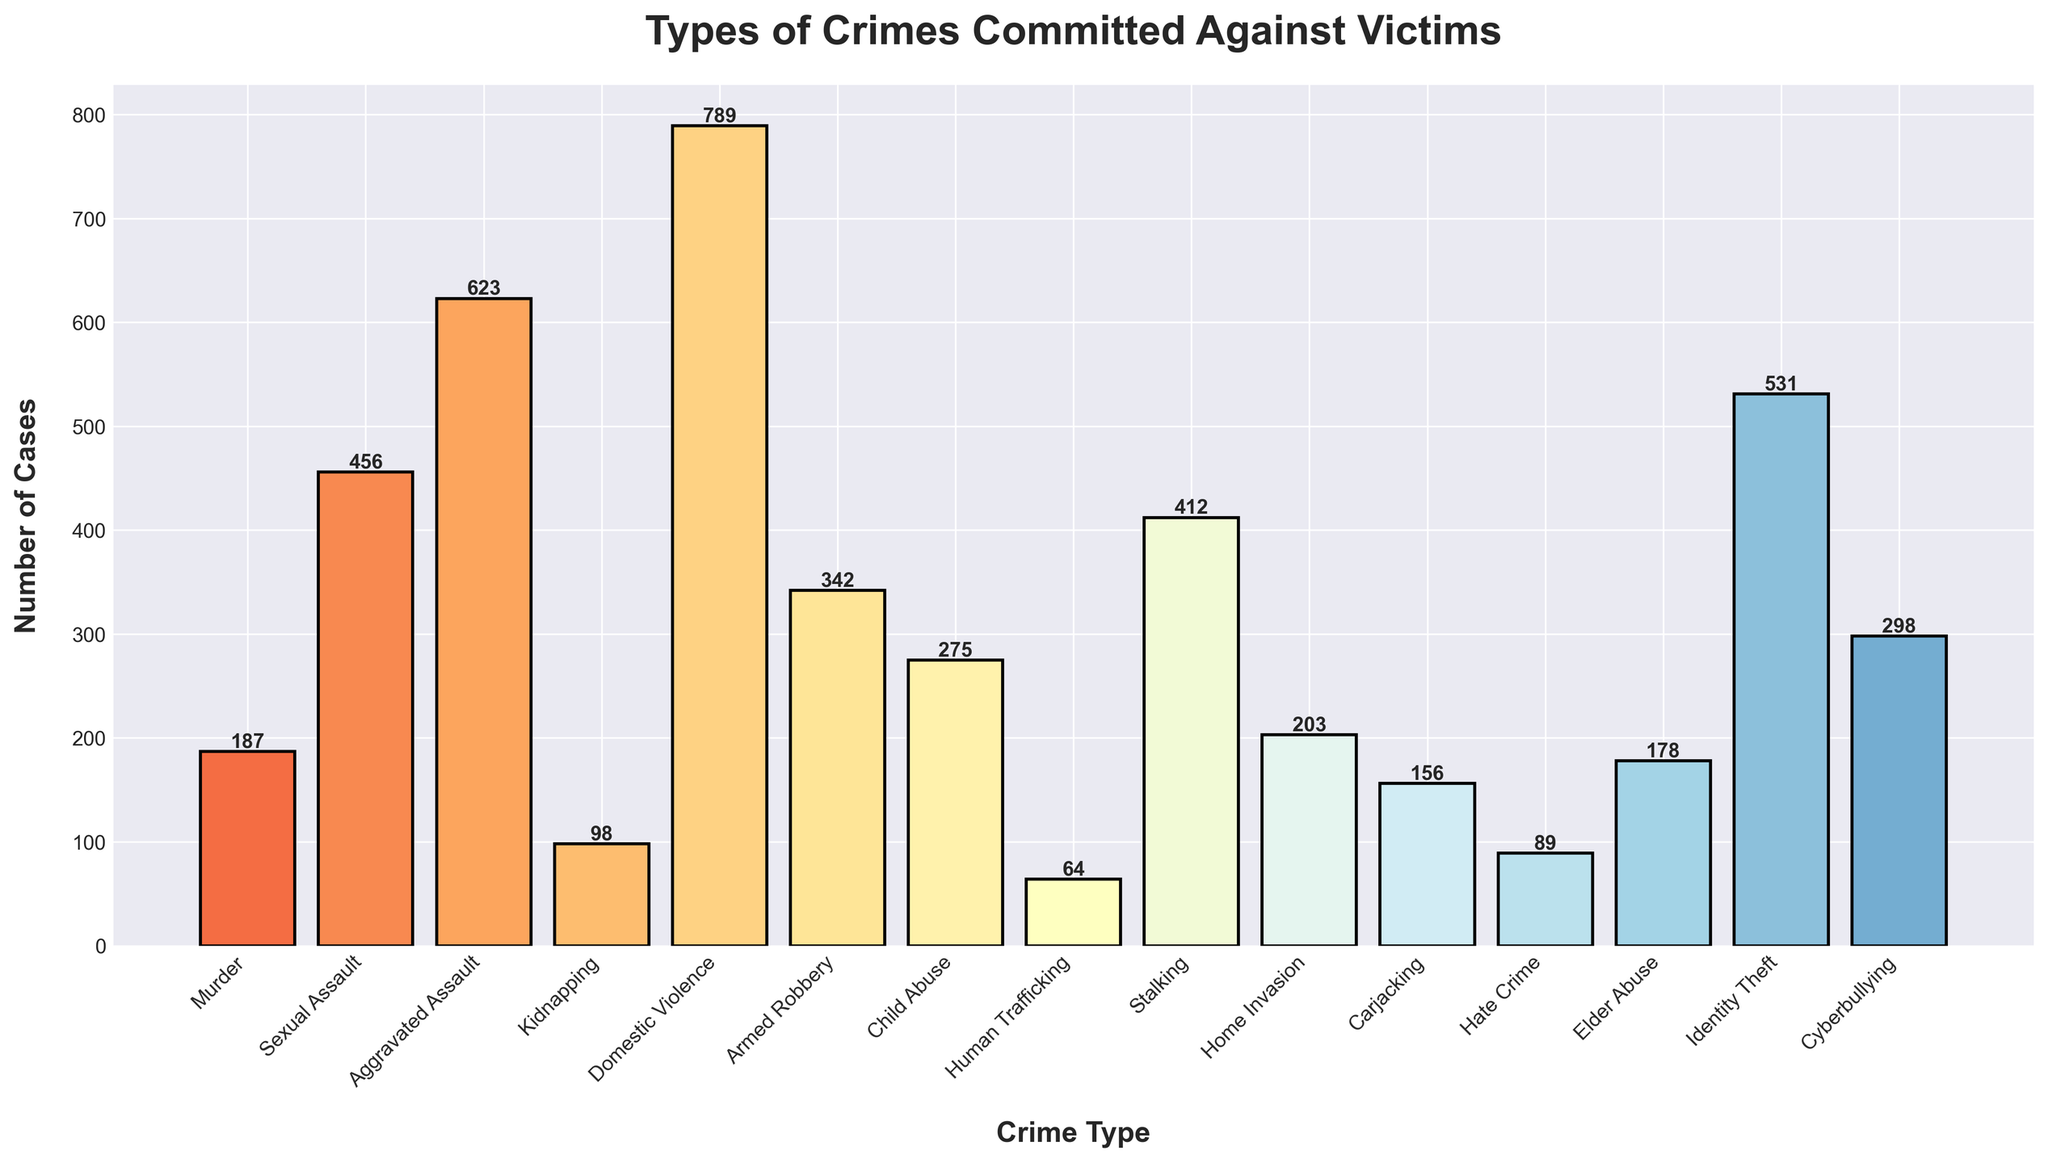Which type of crime has the highest number of cases? The highest bar in the chart corresponds to the type of crime with the highest number of cases. The bar for Domestic Violence is the tallest, indicating it has the highest number of cases.
Answer: Domestic Violence Which type of crime has the lowest number of cases? The shortest bar in the chart corresponds to the type of crime with the lowest number of cases. The bar for Human Trafficking is the shortest, indicating it has the lowest number of cases.
Answer: Human Trafficking How many more cases of Aggravated Assault are there compared to Murder? Look at the heights of the bars for Aggravated Assault and Murder. Subtract the number of cases of Murder from the number of cases of Aggravated Assault: 623 - 187.
Answer: 436 What is the total number of cases for Domestic Violence, Sexual Assault, and Identity Theft combined? Add the number of cases for Domestic Violence, Sexual Assault, and Identity Theft: 789 + 456 + 531.
Answer: 1,776 What is the average number of cases for Murder, Kidnapping, and Home Invasion? Add the number of cases for Murder, Kidnapping, and Home Invasion, then divide by 3: (187 + 98 + 203) / 3.
Answer: 162.67 Are there more cases of Child Abuse or Elder Abuse? Compare the bar heights of Child Abuse and Elder Abuse. The bar for Child Abuse is taller than the bar for Elder Abuse.
Answer: Child Abuse What is the difference in the number of cases between Stalking and Carjacking? Subtract the number of cases of Carjacking from Stalking: 412 - 156.
Answer: 256 What percentage of the total number of cases is accounted for by Cyberbullying? Sum the number of cases for all crime types, then find the percentage that Cyberbullying accounts for by dividing Cyberbullying cases by the total number of cases and multiplying by 100: (298 / 4,721) * 100.
Answer: ~6.31% Between Armed Robbery and Home Invasion, which crime type has fewer cases, and by how much? Compare the number of cases for Armed Robbery and Home Invasion. Armed Robbery has fewer cases. Subtract the number of cases of Armed Robbery from Home Invasion: 203 - 342.
Answer: Armed Robbery by 139 